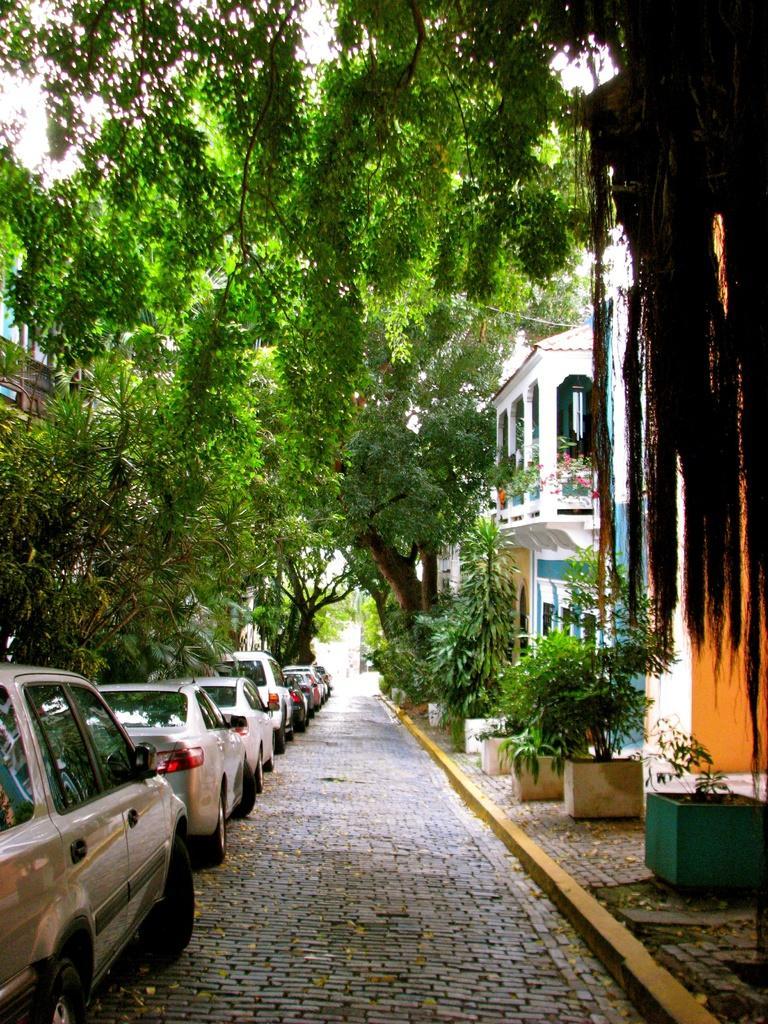Please provide a concise description of this image. In this image we can see few cars parked on the floor, there are few buildings and trees in front of the building and there are few potted plants. 